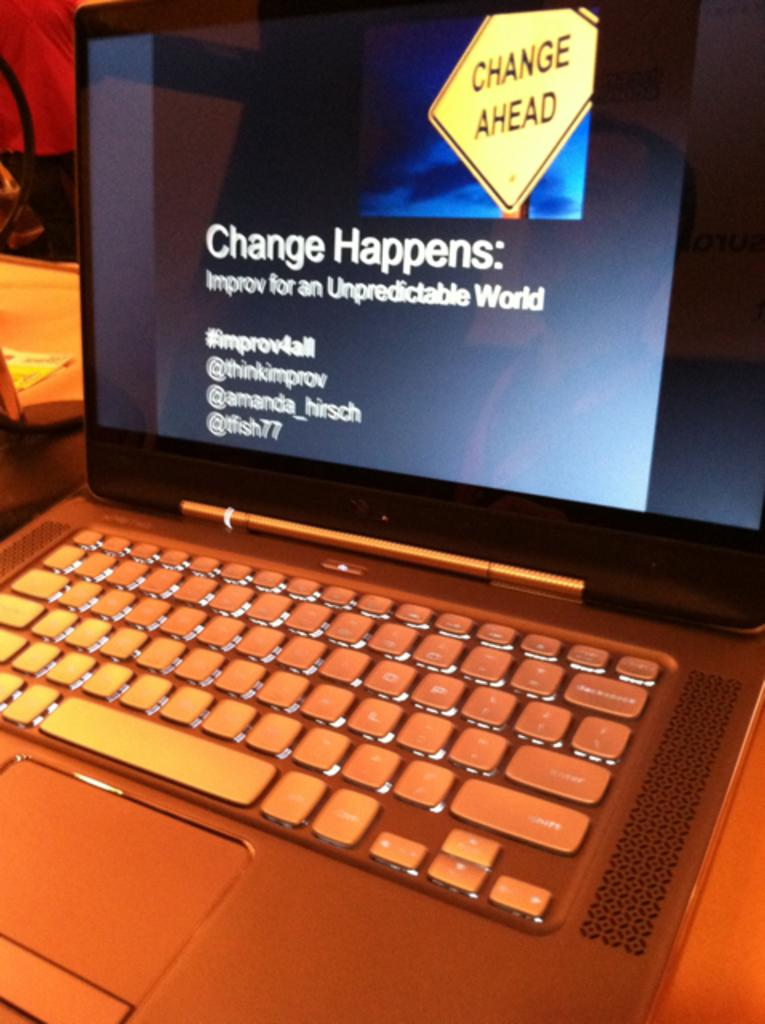<image>
Present a compact description of the photo's key features. The screen of a laptop computer displays information about change. 